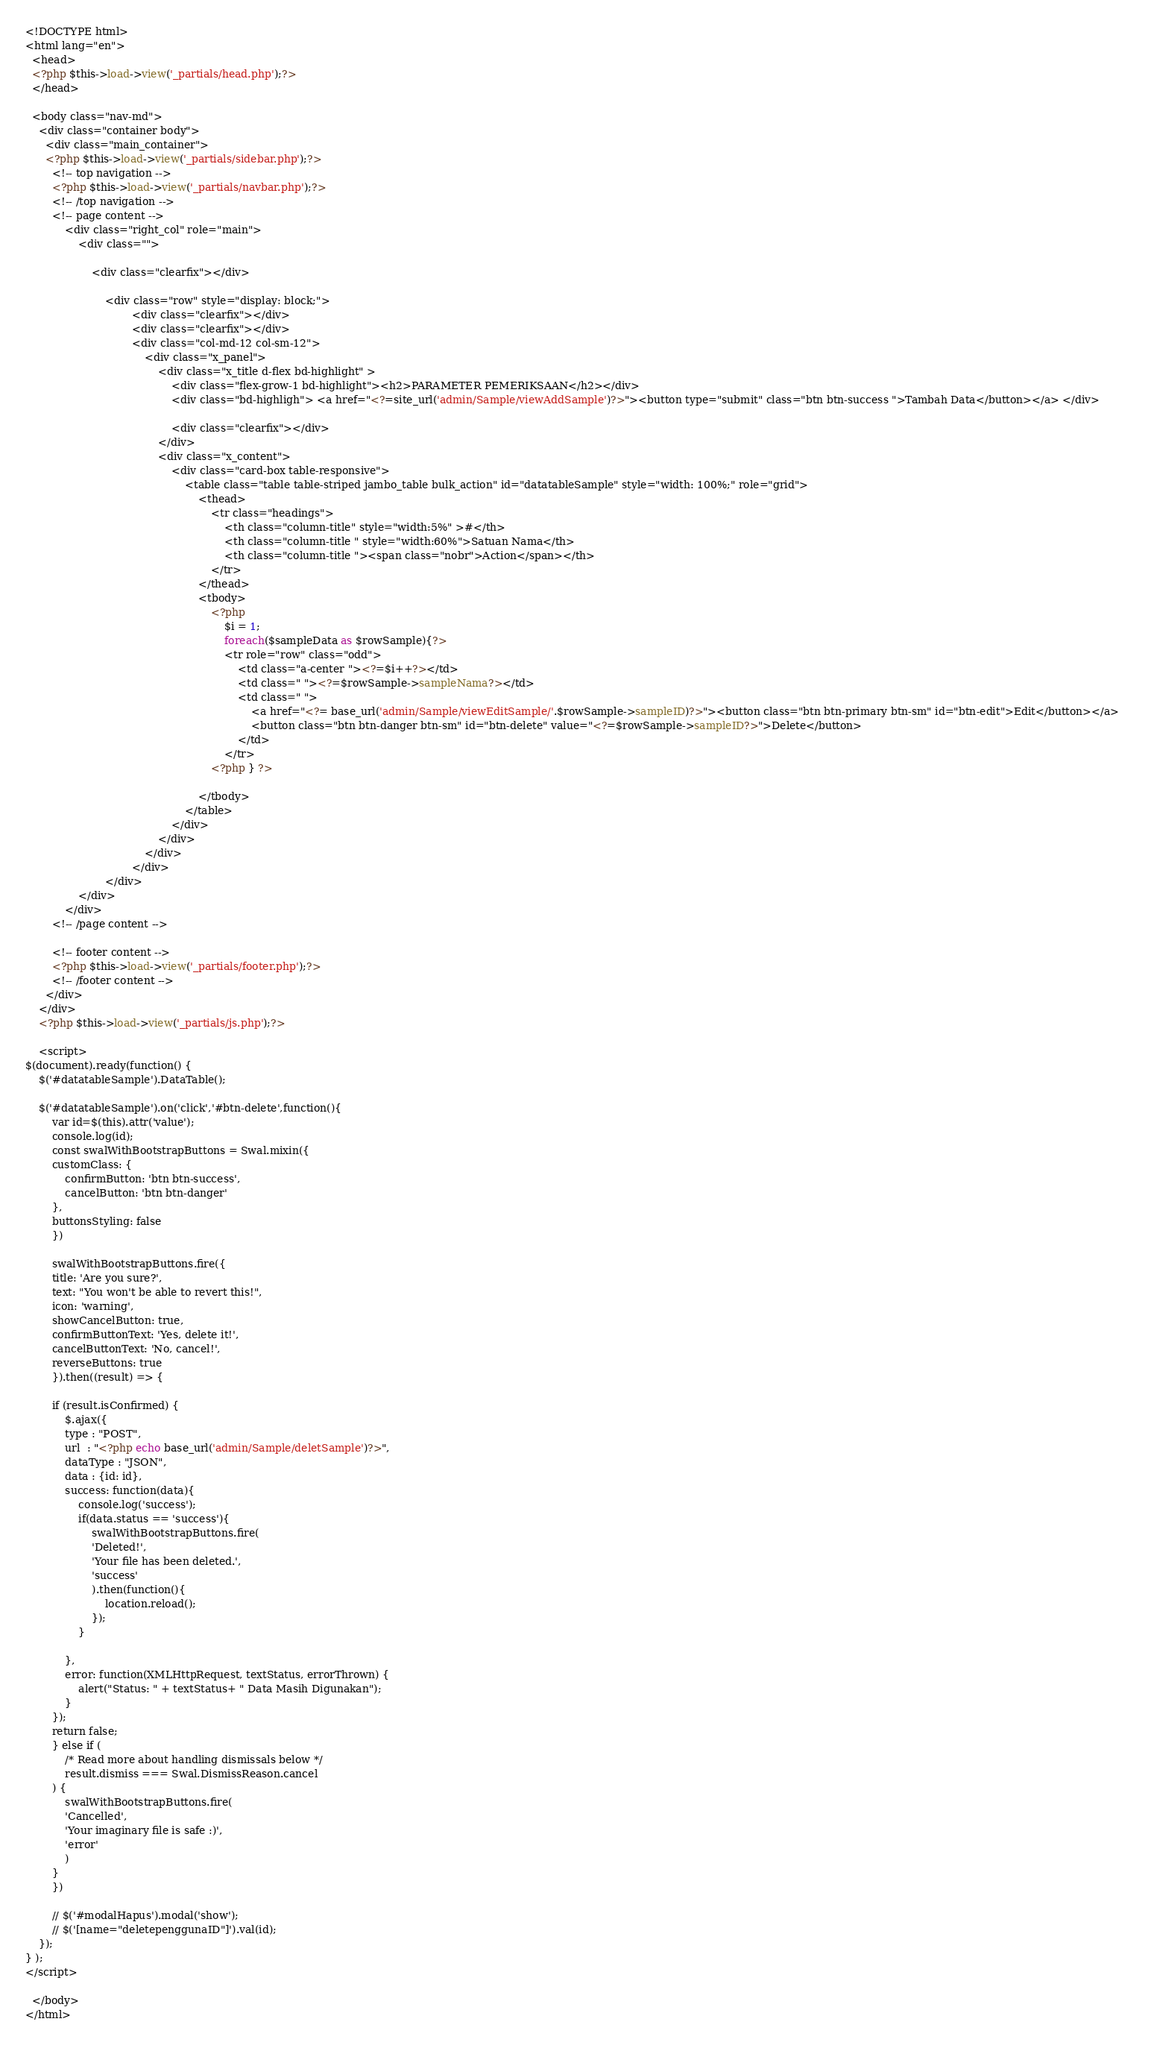<code> <loc_0><loc_0><loc_500><loc_500><_PHP_>
<!DOCTYPE html>
<html lang="en">
  <head>
  <?php $this->load->view('_partials/head.php');?>
  </head>

  <body class="nav-md">
    <div class="container body">
      <div class="main_container">
      <?php $this->load->view('_partials/sidebar.php');?>
        <!-- top navigation -->
        <?php $this->load->view('_partials/navbar.php');?>
        <!-- /top navigation -->
        <!-- page content -->
            <div class="right_col" role="main">
                <div class="">
                   
                    <div class="clearfix"></div>
               
                        <div class="row" style="display: block;">
                                <div class="clearfix"></div>
                                <div class="clearfix"></div>
                                <div class="col-md-12 col-sm-12">
                                    <div class="x_panel">
                                        <div class="x_title d-flex bd-highlight" >
                                            <div class="flex-grow-1 bd-highlight"><h2>PARAMETER PEMERIKSAAN</h2></div>
                                            <div class="bd-highligh"> <a href="<?=site_url('admin/Sample/viewAddSample')?>"><button type="submit" class="btn btn-success ">Tambah Data</button></a> </div>
                                           
                                            <div class="clearfix"></div>
                                        </div>
                                        <div class="x_content">
                                            <div class="card-box table-responsive">
                                                <table class="table table-striped jambo_table bulk_action" id="datatableSample" style="width: 100%;" role="grid">
                                                    <thead>
                                                        <tr class="headings">
                                                            <th class="column-title" style="width:5%" >#</th>
                                                            <th class="column-title " style="width:60%">Satuan Nama</th>
                                                            <th class="column-title "><span class="nobr">Action</span></th>
                                                        </tr>
                                                    </thead>
                                                    <tbody>
                                                        <?php 
                                                            $i = 1;
                                                            foreach($sampleData as $rowSample){?>
                                                            <tr role="row" class="odd">
                                                                <td class="a-center "><?=$i++?></td>
                                                                <td class=" "><?=$rowSample->sampleNama?></td>
                                                                <td class=" ">
                                                                    <a href="<?= base_url('admin/Sample/viewEditSample/'.$rowSample->sampleID)?>"><button class="btn btn-primary btn-sm" id="btn-edit">Edit</button></a>  
                                                                    <button class="btn btn-danger btn-sm" id="btn-delete" value="<?=$rowSample->sampleID?>">Delete</button>
                                                                </td>
                                                            </tr>
                                                        <?php } ?>
                                                        
                                                    </tbody>
                                                </table>
                                            </div>
                                        </div>                                            
                                    </div>
                                </div>
                        </div>
                </div>
            </div>
        <!-- /page content -->

        <!-- footer content -->
        <?php $this->load->view('_partials/footer.php');?>
        <!-- /footer content -->
      </div>
    </div>
    <?php $this->load->view('_partials/js.php');?>

    <script>
$(document).ready(function() {
    $('#datatableSample').DataTable();

    $('#datatableSample').on('click','#btn-delete',function(){
        var id=$(this).attr('value');
        console.log(id);
        const swalWithBootstrapButtons = Swal.mixin({
        customClass: {
            confirmButton: 'btn btn-success',
            cancelButton: 'btn btn-danger'
        },
        buttonsStyling: false
        })

        swalWithBootstrapButtons.fire({
        title: 'Are you sure?',
        text: "You won't be able to revert this!",
        icon: 'warning',
        showCancelButton: true,
        confirmButtonText: 'Yes, delete it!',
        cancelButtonText: 'No, cancel!',
        reverseButtons: true
        }).then((result) => {
            
        if (result.isConfirmed) {
            $.ajax({
            type : "POST",
            url  : "<?php echo base_url('admin/Sample/deletSample')?>",
            dataType : "JSON",
            data : {id: id},
            success: function(data){
                console.log('success');
                if(data.status == 'success'){
                    swalWithBootstrapButtons.fire(
                    'Deleted!',
                    'Your file has been deleted.',
                    'success'
                    ).then(function(){
                        location.reload();
                    });  
                }
                               
            },
            error: function(XMLHttpRequest, textStatus, errorThrown) { 
                alert("Status: " + textStatus+ " Data Masih Digunakan");
            }      
        });
        return false;
        } else if (
            /* Read more about handling dismissals below */
            result.dismiss === Swal.DismissReason.cancel
        ) {
            swalWithBootstrapButtons.fire(
            'Cancelled',
            'Your imaginary file is safe :)',
            'error'
            )
        }
        })

        // $('#modalHapus').modal('show');
        // $('[name="deletepenggunaID"]').val(id);
    });
} );
</script>
   
  </body>
</html>
</code> 